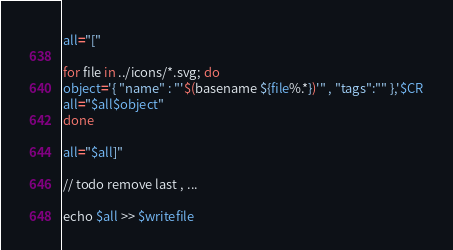<code> <loc_0><loc_0><loc_500><loc_500><_Bash_>all="["

for file in ../icons/*.svg; do
object='{ "name" : "'$(basename ${file%.*})'" , "tags":"" },'$CR
all="$all$object"
done

all="$all]"

// todo remove last , ...

echo $all >> $writefile
</code> 